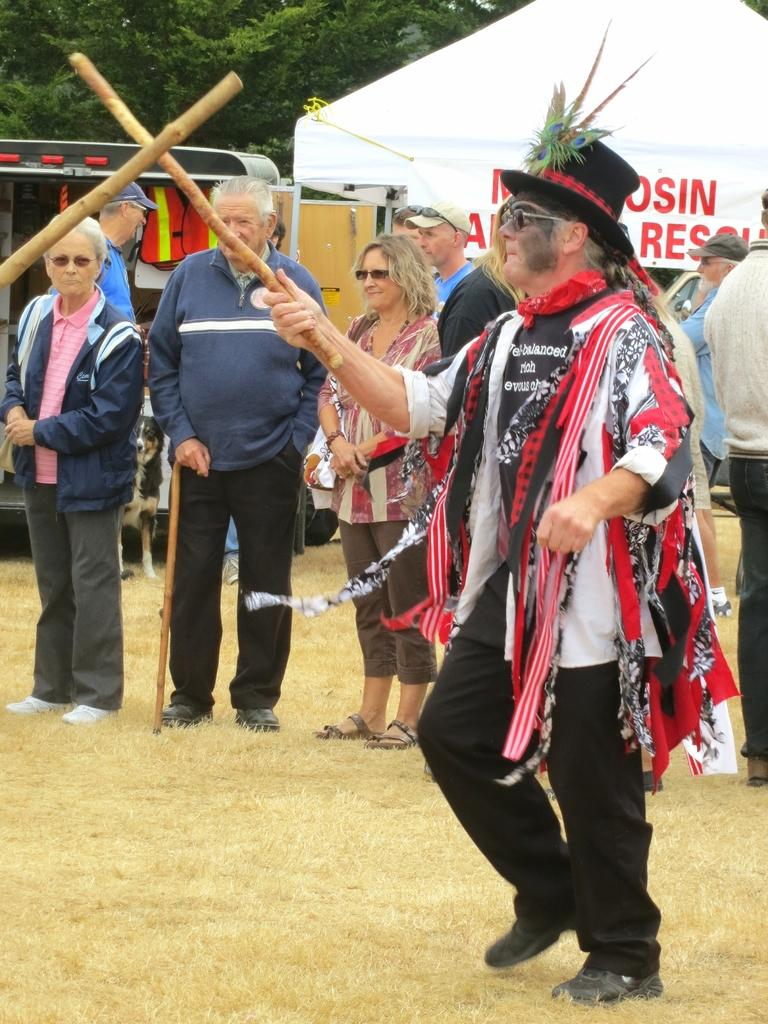What is the person in the image wearing on their head? The person in the image is wearing a hat. What is the person holding in the image? The person is holding a stick. What can be seen in the background of the image? There is a group of people, a stall, a vehicle, and trees in the background. What type of cave can be seen in the background of the image? There is no cave present in the image; it features a person with a hat, a stick, and various elements in the background. 